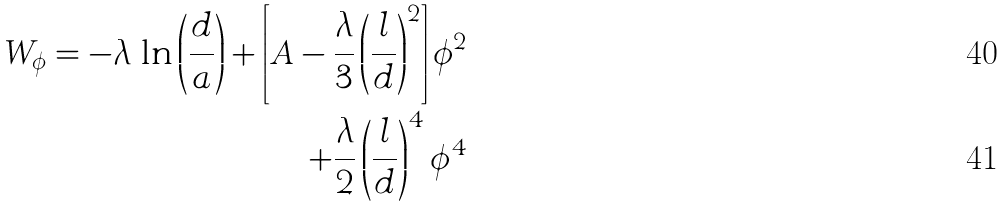<formula> <loc_0><loc_0><loc_500><loc_500>W _ { \phi } = - \lambda \, \ln \left ( \frac { d } { a } \right ) + \left [ A - \frac { \lambda } { 3 } \left ( \frac { l } { d } \right ) ^ { 2 } \right ] \phi ^ { 2 } \\ + \frac { \lambda } { 2 } \left ( \frac { l } { d } \right ) ^ { 4 } \phi ^ { 4 }</formula> 